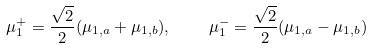Convert formula to latex. <formula><loc_0><loc_0><loc_500><loc_500>\mu _ { 1 } ^ { + } = \frac { \sqrt { 2 } } { 2 } ( \mu _ { 1 , a } + \mu _ { 1 , b } ) , \quad \mu _ { 1 } ^ { - } = \frac { \sqrt { 2 } } { 2 } ( \mu _ { 1 , a } - \mu _ { 1 , b } )</formula> 